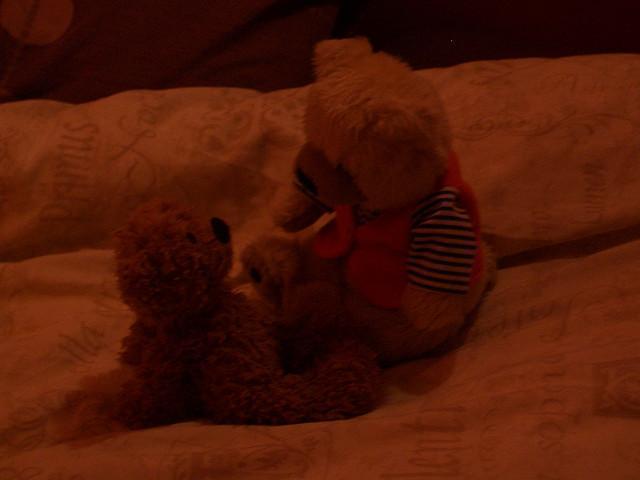How many teddy bears are here?
Give a very brief answer. 2. How many teddy bears are there?
Give a very brief answer. 2. 